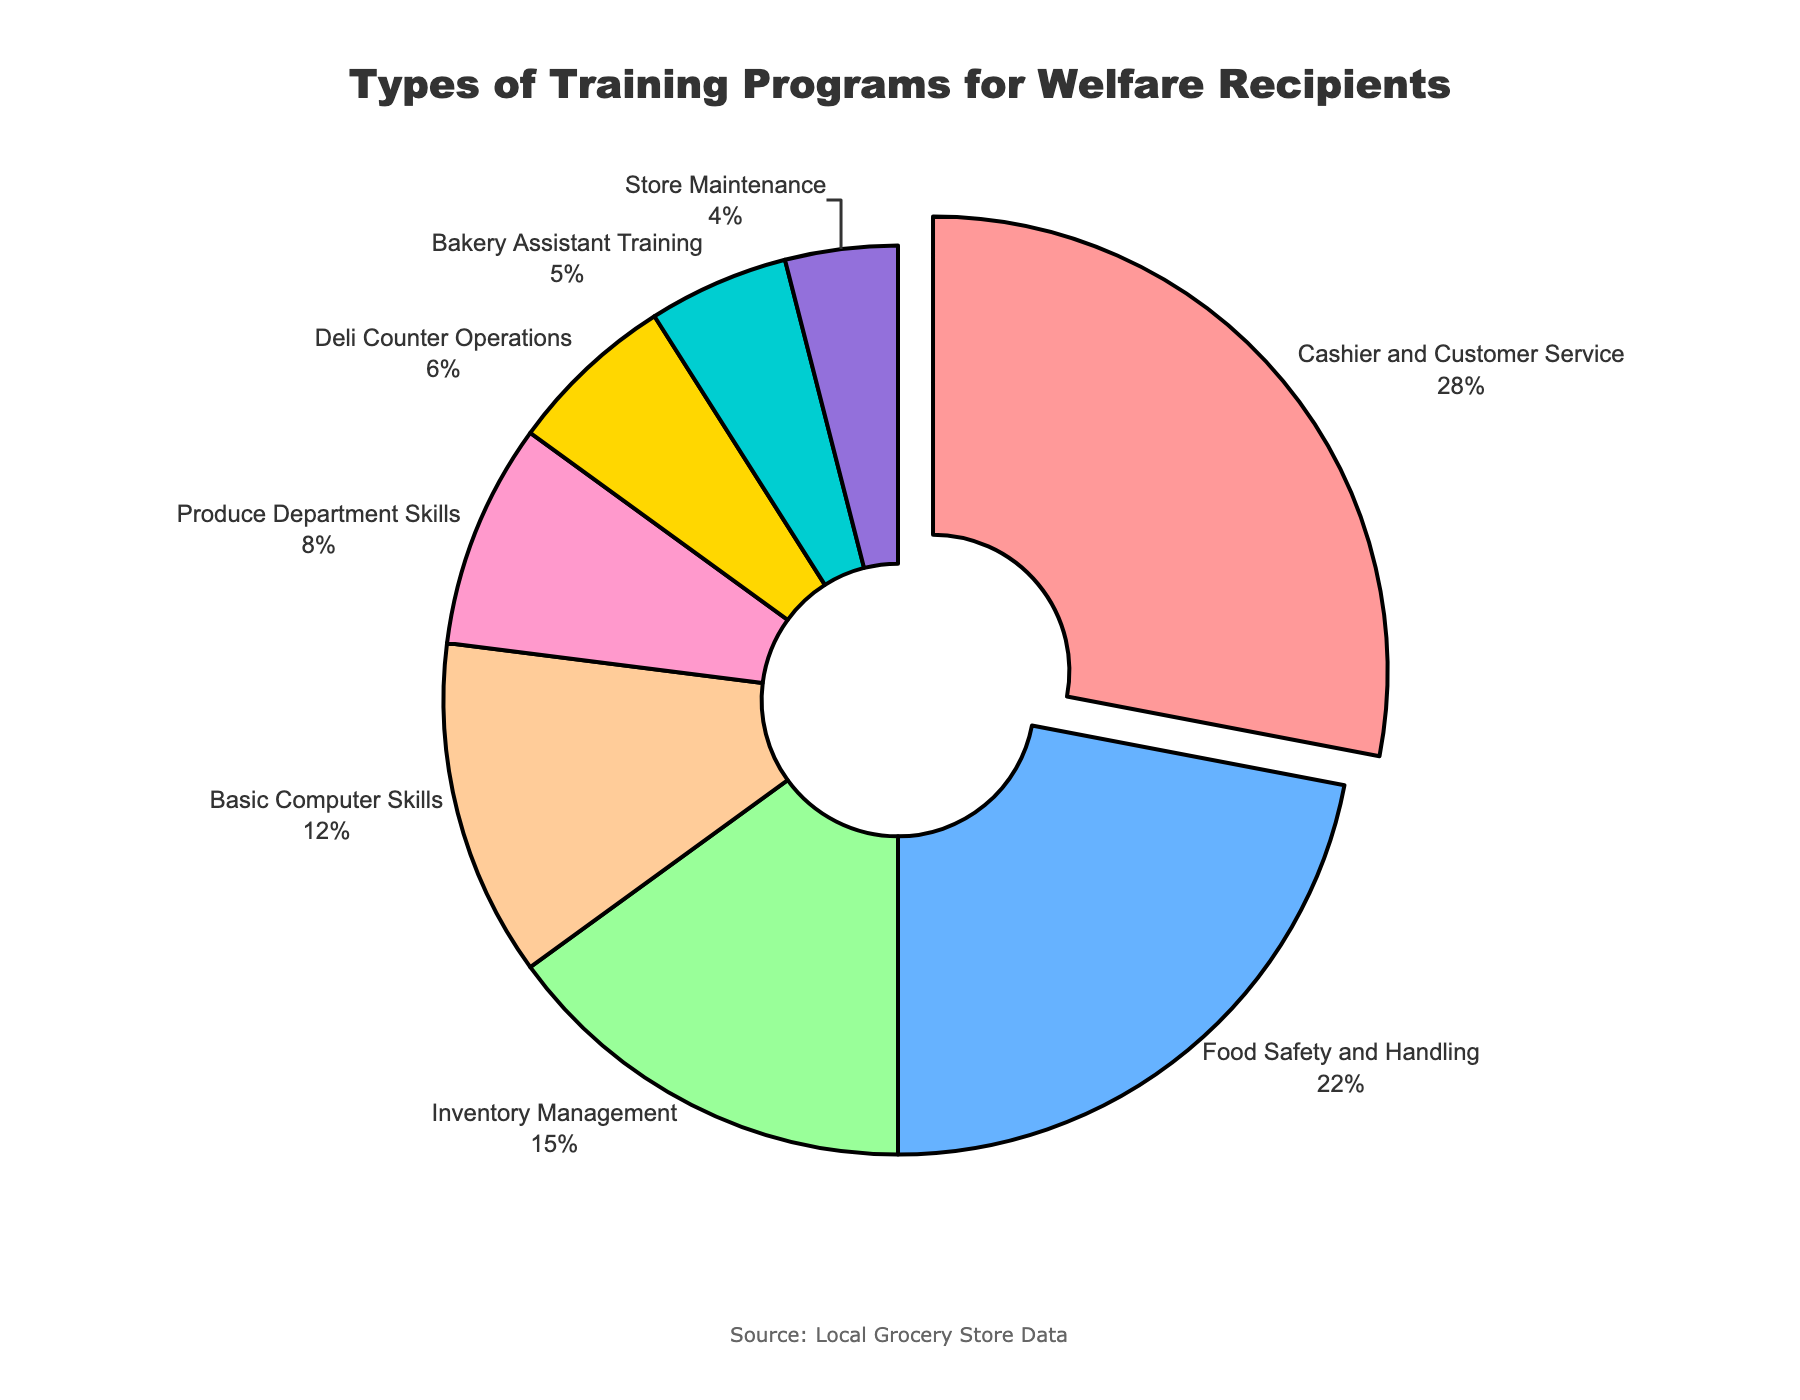What is the most common training program offered to welfare recipients? The figure shows pie slices, where "Cashier and Customer Service" has the largest percentage share at 28%.
Answer: Cashier and Customer Service Which training program has a lower percentage, Food Safety and Handling or Inventory Management? By looking at the pie chart, "Food Safety and Handling" has 22% and "Inventory Management" has 15%.
Answer: Inventory Management What is the combined percentage of "Basic Computer Skills" and "Produce Department Skills"? From the figure, "Basic Computer Skills" is 12% and "Produce Department Skills" is 8%. Combined, that is 12% + 8% = 20%.
Answer: 20% How much larger is the percentage of "Cashier and Customer Service" compared to "Bakery Assistant Training"? The chart shows that "Cashier and Customer Service" is 28% and "Bakery Assistant Training" is 5%. The difference is 28% - 5% = 23%.
Answer: 23% Which training programs make up less than 10% each of the total offerings? From the pie chart, "Produce Department Skills" (8%), "Deli Counter Operations" (6%), "Bakery Assistant Training" (5%), and "Store Maintenance" (4%) each constitute less than 10%.
Answer: Produce Department Skills, Deli Counter Operations, Bakery Assistant Training, Store Maintenance By how much does the percentage of "Food Safety and Handling" exceed that of "Store Maintenance"? The pie slices show "Food Safety and Handling" at 22% and "Store Maintenance" at 4%. The difference is 22% - 4% = 18%.
Answer: 18% What two training programs together account for the largest share of offerings, and what is their combined percentage? According to the figure, "Cashier and Customer Service" (28%) and "Food Safety and Handling" (22%) together account for the largest share. Combined, that is 28% + 22% = 50%.
Answer: Cashier and Customer Service and Food Safety and Handling, 50% Arrange the training programs in descending order of their percentages. By examining the pie chart visually, the order from largest to smallest is "Cashier and Customer Service" (28%), "Food Safety and Handling" (22%), "Inventory Management" (15%), "Basic Computer Skills" (12%), "Produce Department Skills" (8%), "Deli Counter Operations" (6%), "Bakery Assistant Training" (5%), and "Store Maintenance" (4%).
Answer: Cashier and Customer Service, Food Safety and Handling, Inventory Management, Basic Computer Skills, Produce Department Skills, Deli Counter Operations, Bakery Assistant Training, Store Maintenance 